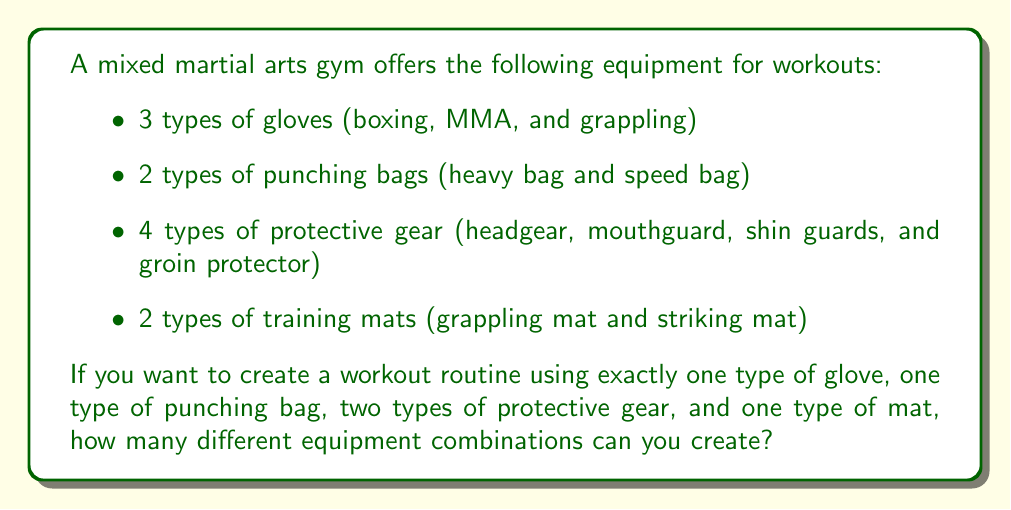Can you solve this math problem? Let's break this problem down step by step using the multiplication principle of counting:

1) First, we need to choose one type of glove out of 3 options:
   $\binom{3}{1} = 3$ ways

2) Then, we choose one type of punching bag out of 2 options:
   $\binom{2}{1} = 2$ ways

3) Next, we need to choose two types of protective gear out of 4 options:
   $\binom{4}{2} = \frac{4!}{2!(4-2)!} = \frac{4 \cdot 3}{2 \cdot 1} = 6$ ways

4) Finally, we choose one type of mat out of 2 options:
   $\binom{2}{1} = 2$ ways

Now, according to the multiplication principle, the total number of combinations is the product of the number of ways for each choice:

$$ 3 \cdot 2 \cdot 6 \cdot 2 = 72 $$

Therefore, there are 72 different equipment combinations possible.
Answer: 72 combinations 